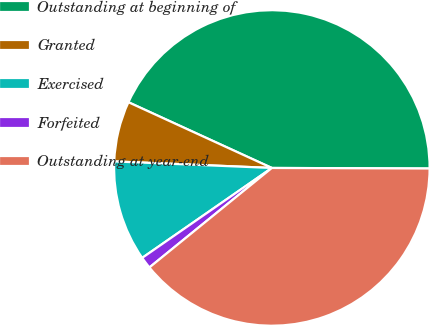Convert chart. <chart><loc_0><loc_0><loc_500><loc_500><pie_chart><fcel>Outstanding at beginning of<fcel>Granted<fcel>Exercised<fcel>Forfeited<fcel>Outstanding at year-end<nl><fcel>43.21%<fcel>6.18%<fcel>10.31%<fcel>1.21%<fcel>39.08%<nl></chart> 